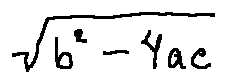Convert formula to latex. <formula><loc_0><loc_0><loc_500><loc_500>\sqrt { b ^ { 2 } - 4 a c }</formula> 